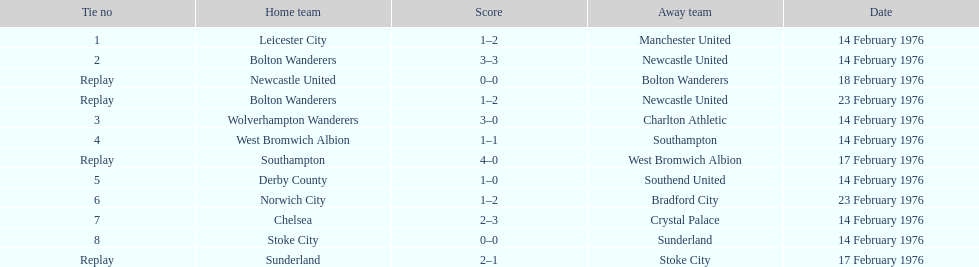Who had a better score, manchester united or wolverhampton wanderers? Wolverhampton Wanderers. 